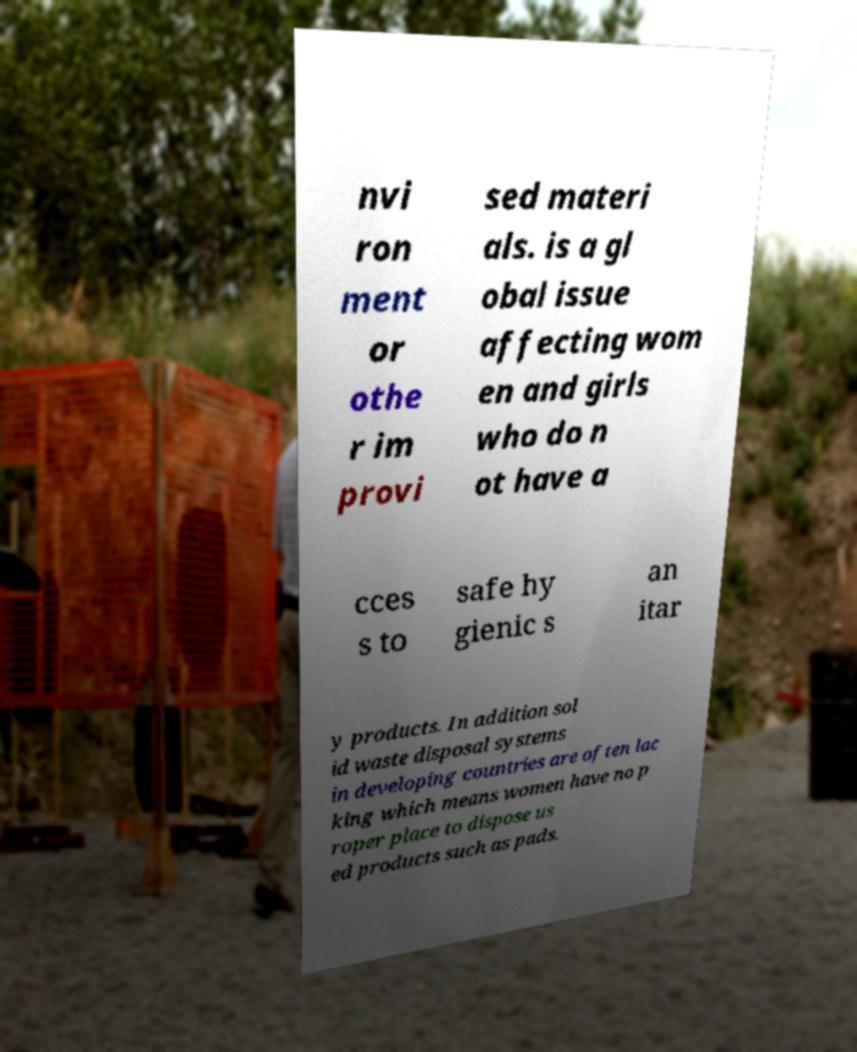Could you extract and type out the text from this image? nvi ron ment or othe r im provi sed materi als. is a gl obal issue affecting wom en and girls who do n ot have a cces s to safe hy gienic s an itar y products. In addition sol id waste disposal systems in developing countries are often lac king which means women have no p roper place to dispose us ed products such as pads. 